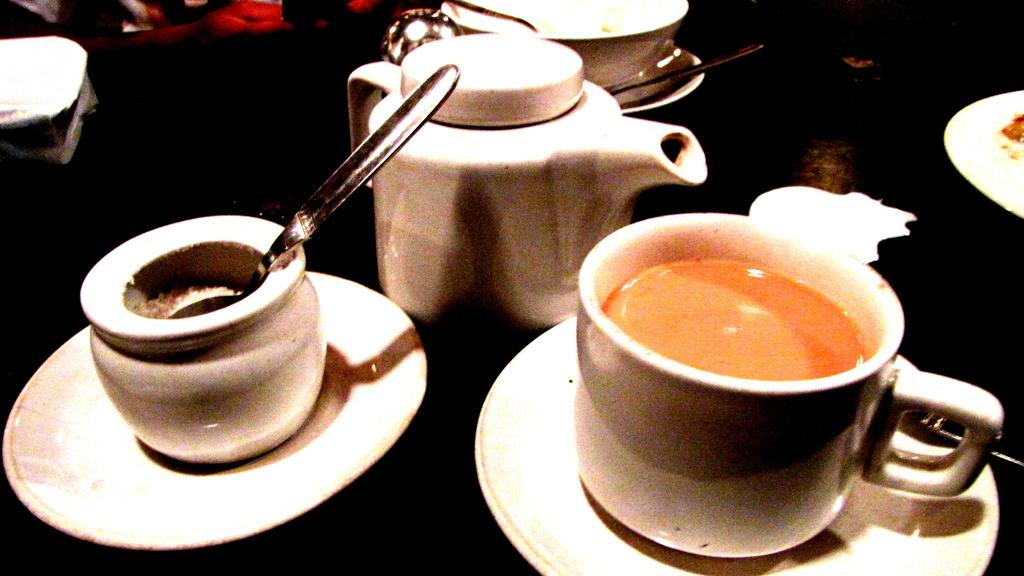What is the main object in the center of the image? There is a table in the center of the image. What can be found on the table? There is a cup, saucers, a jar, a spoon, and a pot on the table. What might be used for drinking in the image? The cup on the table might be used for drinking. What is the purpose of the saucers on the table? The saucers on the table might be used to hold the cup or other items. What type of health benefits can be gained from the gold in the image? There is no gold present in the image, so no health benefits can be gained from it. 